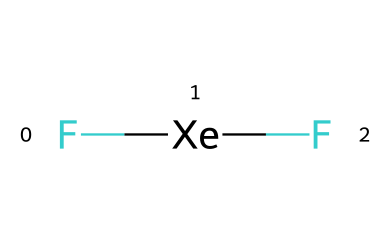What is the name of this compound? The chemical structure represented by the SMILES notation indicates that it consists of xenon and fluorine atoms, which leads to the name "xenon difluoride."
Answer: xenon difluoride How many fluorine atoms are present in this compound? The SMILES representation shows "F[Xe]F," which indicates there are two fluorine atoms bonded to one xenon atom.
Answer: 2 What type of bonding is present in xenon difluoride? The SMILES notation shows fluorine atoms directly bonded to the xenon atom, indicating that this compound has covalent bonds.
Answer: covalent What is the central atom in xenon difluoride? In the SMILES "F[Xe]F," the central atom is specified by the symbol [Xe], identifying it as xenon.
Answer: xenon Is xenon difluoride considered a halogen compound? This compound contains fluorine, which is a halogen, and it showcases properties associated with halogen derivatives.
Answer: yes What is the hybridization state of the xenon atom in this compound? Looking at its structure, xenon in xenon difluoride is involved in four electron pairs (two bonds and two lone pairs), indicating sp3 hybridization.
Answer: sp3 